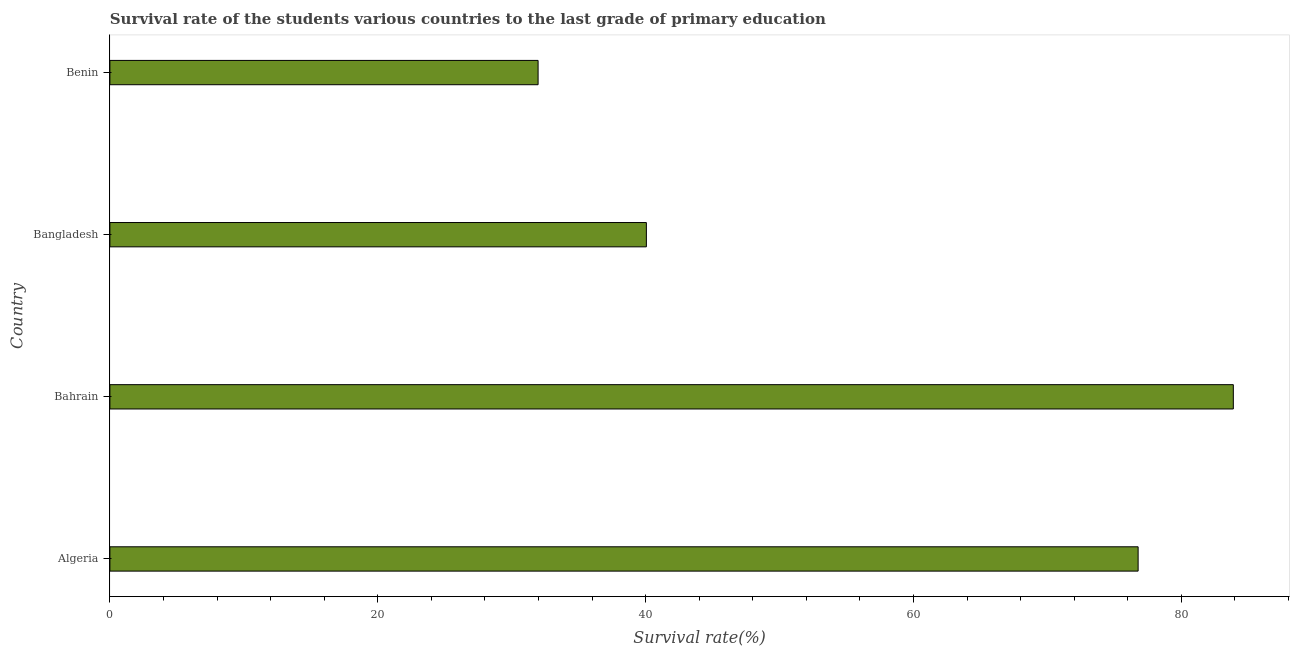What is the title of the graph?
Provide a short and direct response. Survival rate of the students various countries to the last grade of primary education. What is the label or title of the X-axis?
Your answer should be compact. Survival rate(%). What is the label or title of the Y-axis?
Your response must be concise. Country. What is the survival rate in primary education in Benin?
Your answer should be very brief. 31.97. Across all countries, what is the maximum survival rate in primary education?
Provide a short and direct response. 83.89. Across all countries, what is the minimum survival rate in primary education?
Ensure brevity in your answer.  31.97. In which country was the survival rate in primary education maximum?
Offer a terse response. Bahrain. In which country was the survival rate in primary education minimum?
Your response must be concise. Benin. What is the sum of the survival rate in primary education?
Your response must be concise. 232.7. What is the difference between the survival rate in primary education in Algeria and Benin?
Your response must be concise. 44.8. What is the average survival rate in primary education per country?
Keep it short and to the point. 58.17. What is the median survival rate in primary education?
Ensure brevity in your answer.  58.42. In how many countries, is the survival rate in primary education greater than 36 %?
Your response must be concise. 3. What is the ratio of the survival rate in primary education in Algeria to that in Benin?
Offer a very short reply. 2.4. What is the difference between the highest and the second highest survival rate in primary education?
Offer a very short reply. 7.11. What is the difference between the highest and the lowest survival rate in primary education?
Your answer should be very brief. 51.91. Are the values on the major ticks of X-axis written in scientific E-notation?
Your answer should be compact. No. What is the Survival rate(%) in Algeria?
Keep it short and to the point. 76.78. What is the Survival rate(%) of Bahrain?
Your answer should be compact. 83.89. What is the Survival rate(%) in Bangladesh?
Your answer should be compact. 40.06. What is the Survival rate(%) of Benin?
Your answer should be compact. 31.97. What is the difference between the Survival rate(%) in Algeria and Bahrain?
Provide a short and direct response. -7.11. What is the difference between the Survival rate(%) in Algeria and Bangladesh?
Provide a succinct answer. 36.72. What is the difference between the Survival rate(%) in Algeria and Benin?
Offer a terse response. 44.8. What is the difference between the Survival rate(%) in Bahrain and Bangladesh?
Your answer should be very brief. 43.83. What is the difference between the Survival rate(%) in Bahrain and Benin?
Offer a terse response. 51.91. What is the difference between the Survival rate(%) in Bangladesh and Benin?
Offer a terse response. 8.08. What is the ratio of the Survival rate(%) in Algeria to that in Bahrain?
Ensure brevity in your answer.  0.92. What is the ratio of the Survival rate(%) in Algeria to that in Bangladesh?
Keep it short and to the point. 1.92. What is the ratio of the Survival rate(%) in Algeria to that in Benin?
Ensure brevity in your answer.  2.4. What is the ratio of the Survival rate(%) in Bahrain to that in Bangladesh?
Provide a succinct answer. 2.09. What is the ratio of the Survival rate(%) in Bahrain to that in Benin?
Provide a succinct answer. 2.62. What is the ratio of the Survival rate(%) in Bangladesh to that in Benin?
Your answer should be compact. 1.25. 